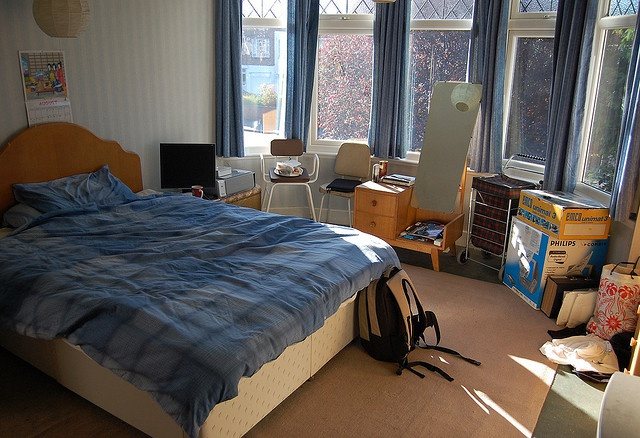Describe the objects in this image and their specific colors. I can see bed in black, gray, darkblue, and maroon tones, backpack in black, maroon, and gray tones, tv in black, gray, and darkgray tones, chair in black, gray, maroon, and darkgray tones, and chair in black and gray tones in this image. 